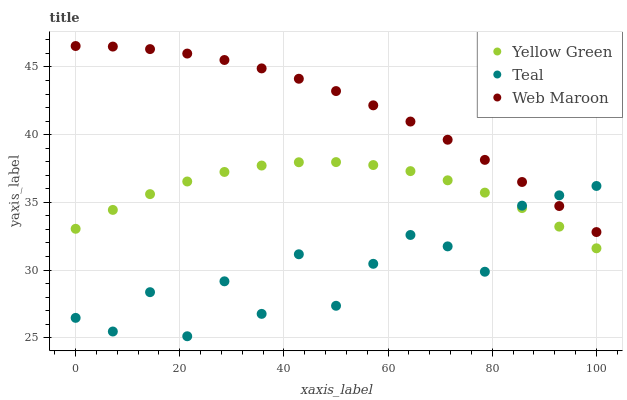Does Teal have the minimum area under the curve?
Answer yes or no. Yes. Does Web Maroon have the maximum area under the curve?
Answer yes or no. Yes. Does Yellow Green have the minimum area under the curve?
Answer yes or no. No. Does Yellow Green have the maximum area under the curve?
Answer yes or no. No. Is Web Maroon the smoothest?
Answer yes or no. Yes. Is Teal the roughest?
Answer yes or no. Yes. Is Yellow Green the smoothest?
Answer yes or no. No. Is Yellow Green the roughest?
Answer yes or no. No. Does Teal have the lowest value?
Answer yes or no. Yes. Does Yellow Green have the lowest value?
Answer yes or no. No. Does Web Maroon have the highest value?
Answer yes or no. Yes. Does Yellow Green have the highest value?
Answer yes or no. No. Is Yellow Green less than Web Maroon?
Answer yes or no. Yes. Is Web Maroon greater than Yellow Green?
Answer yes or no. Yes. Does Teal intersect Web Maroon?
Answer yes or no. Yes. Is Teal less than Web Maroon?
Answer yes or no. No. Is Teal greater than Web Maroon?
Answer yes or no. No. Does Yellow Green intersect Web Maroon?
Answer yes or no. No. 